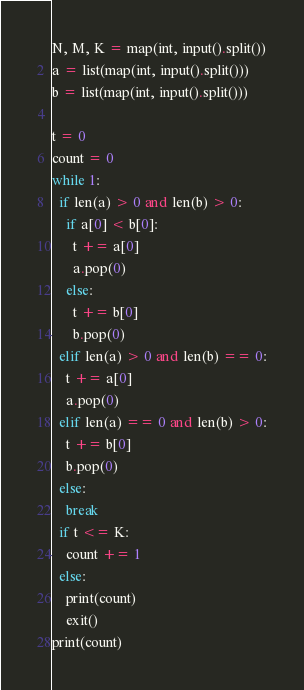<code> <loc_0><loc_0><loc_500><loc_500><_Python_>N, M, K = map(int, input().split())
a = list(map(int, input().split()))
b = list(map(int, input().split()))

t = 0
count = 0
while 1:
  if len(a) > 0 and len(b) > 0:
    if a[0] < b[0]:
      t += a[0]
      a.pop(0)
    else:
      t += b[0]
      b.pop(0)
  elif len(a) > 0 and len(b) == 0:
    t += a[0]
    a.pop(0)
  elif len(a) == 0 and len(b) > 0:
    t += b[0]
    b.pop(0)
  else:
    break
  if t <= K:
    count += 1
  else:
    print(count)
    exit()
print(count)</code> 